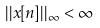<formula> <loc_0><loc_0><loc_500><loc_500>| | x [ n ] | | _ { \infty } < \infty</formula> 